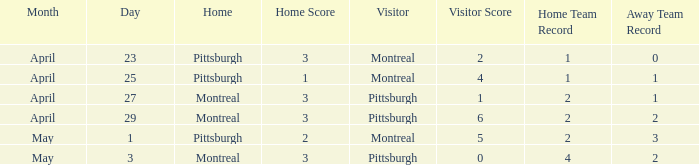When did Montreal visit and have a score of 1-4? April 25. 